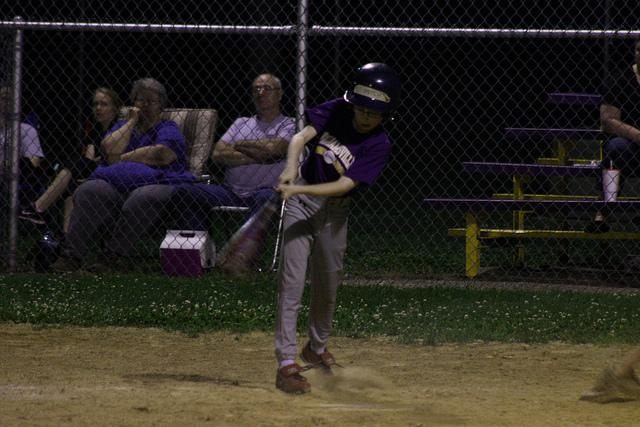If the boy is unsuccessful in doing what he is doing three times in a row what is it called? Please explain your reasoning. strikeout. This game would happen in baseball. he's holding a bat, there's a fence behind him to prevent balls from hitting the audience, and he's wearing those baseball helmets. 